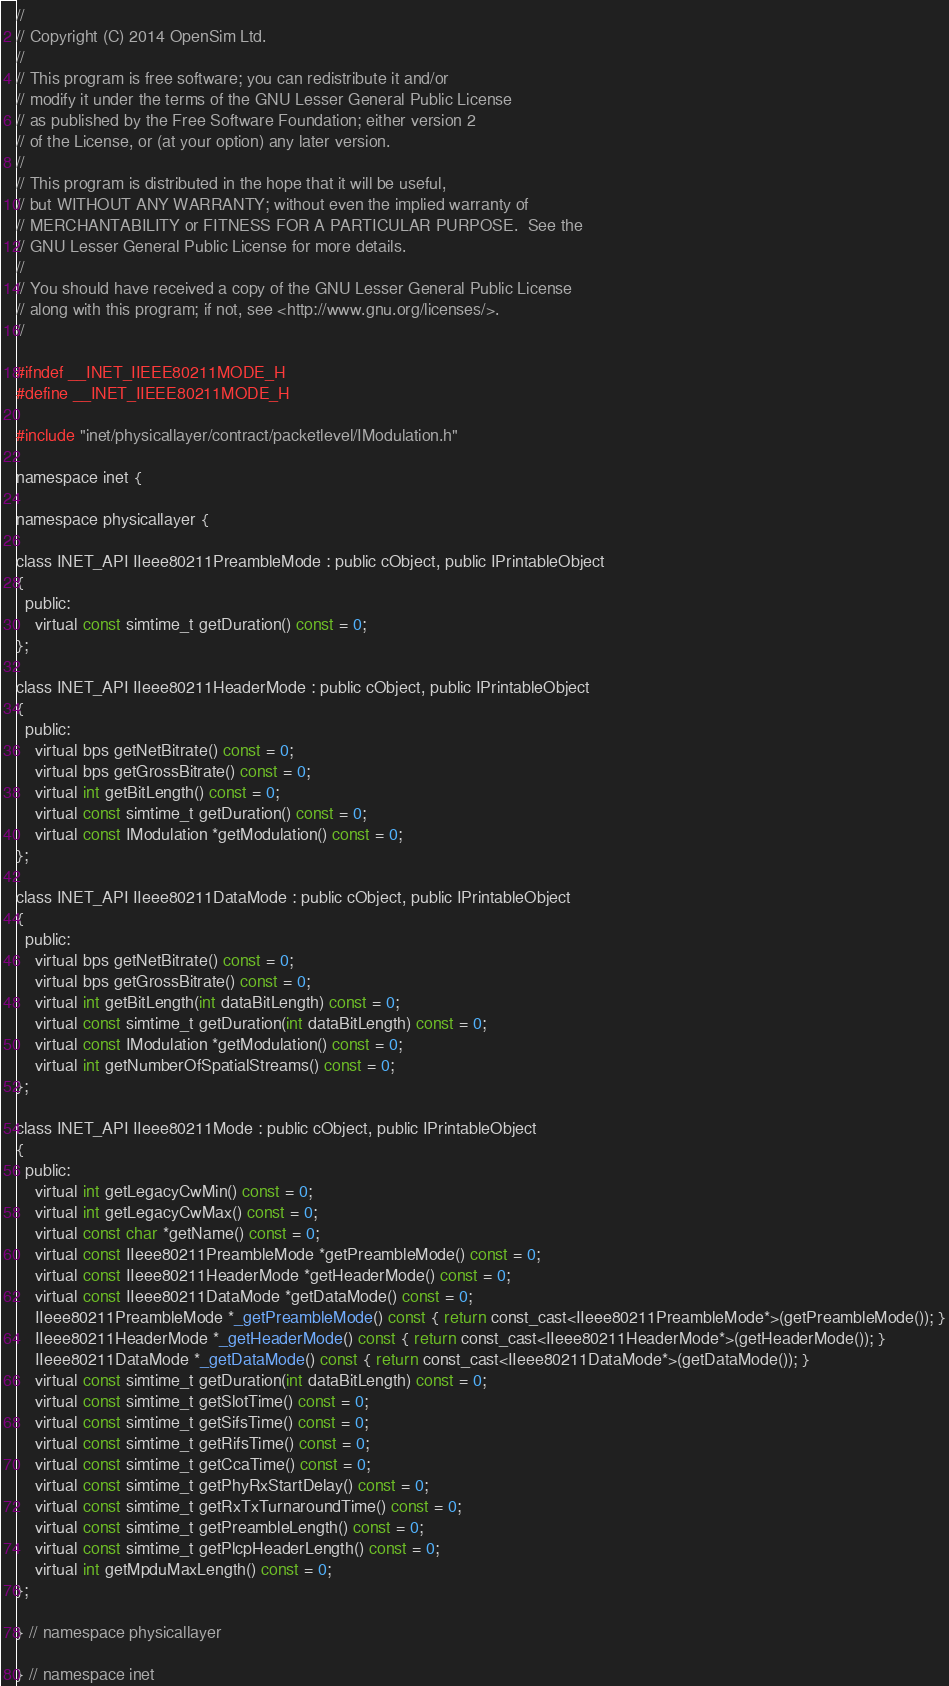Convert code to text. <code><loc_0><loc_0><loc_500><loc_500><_C_>//
// Copyright (C) 2014 OpenSim Ltd.
//
// This program is free software; you can redistribute it and/or
// modify it under the terms of the GNU Lesser General Public License
// as published by the Free Software Foundation; either version 2
// of the License, or (at your option) any later version.
//
// This program is distributed in the hope that it will be useful,
// but WITHOUT ANY WARRANTY; without even the implied warranty of
// MERCHANTABILITY or FITNESS FOR A PARTICULAR PURPOSE.  See the
// GNU Lesser General Public License for more details.
//
// You should have received a copy of the GNU Lesser General Public License
// along with this program; if not, see <http://www.gnu.org/licenses/>.
//

#ifndef __INET_IIEEE80211MODE_H
#define __INET_IIEEE80211MODE_H

#include "inet/physicallayer/contract/packetlevel/IModulation.h"

namespace inet {

namespace physicallayer {

class INET_API IIeee80211PreambleMode : public cObject, public IPrintableObject
{
  public:
    virtual const simtime_t getDuration() const = 0;
};

class INET_API IIeee80211HeaderMode : public cObject, public IPrintableObject
{
  public:
    virtual bps getNetBitrate() const = 0;
    virtual bps getGrossBitrate() const = 0;
    virtual int getBitLength() const = 0;
    virtual const simtime_t getDuration() const = 0;
    virtual const IModulation *getModulation() const = 0;
};

class INET_API IIeee80211DataMode : public cObject, public IPrintableObject
{
  public:
    virtual bps getNetBitrate() const = 0;
    virtual bps getGrossBitrate() const = 0;
    virtual int getBitLength(int dataBitLength) const = 0;
    virtual const simtime_t getDuration(int dataBitLength) const = 0;
    virtual const IModulation *getModulation() const = 0;
    virtual int getNumberOfSpatialStreams() const = 0;
};

class INET_API IIeee80211Mode : public cObject, public IPrintableObject
{
  public:
    virtual int getLegacyCwMin() const = 0;
    virtual int getLegacyCwMax() const = 0;
    virtual const char *getName() const = 0;
    virtual const IIeee80211PreambleMode *getPreambleMode() const = 0;
    virtual const IIeee80211HeaderMode *getHeaderMode() const = 0;
    virtual const IIeee80211DataMode *getDataMode() const = 0;
    IIeee80211PreambleMode *_getPreambleMode() const { return const_cast<IIeee80211PreambleMode*>(getPreambleMode()); }
    IIeee80211HeaderMode *_getHeaderMode() const { return const_cast<IIeee80211HeaderMode*>(getHeaderMode()); }
    IIeee80211DataMode *_getDataMode() const { return const_cast<IIeee80211DataMode*>(getDataMode()); }
    virtual const simtime_t getDuration(int dataBitLength) const = 0;
    virtual const simtime_t getSlotTime() const = 0;
    virtual const simtime_t getSifsTime() const = 0;
    virtual const simtime_t getRifsTime() const = 0;
    virtual const simtime_t getCcaTime() const = 0;
    virtual const simtime_t getPhyRxStartDelay() const = 0;
    virtual const simtime_t getRxTxTurnaroundTime() const = 0;
    virtual const simtime_t getPreambleLength() const = 0;
    virtual const simtime_t getPlcpHeaderLength() const = 0;
    virtual int getMpduMaxLength() const = 0;
};

} // namespace physicallayer

} // namespace inet
</code> 